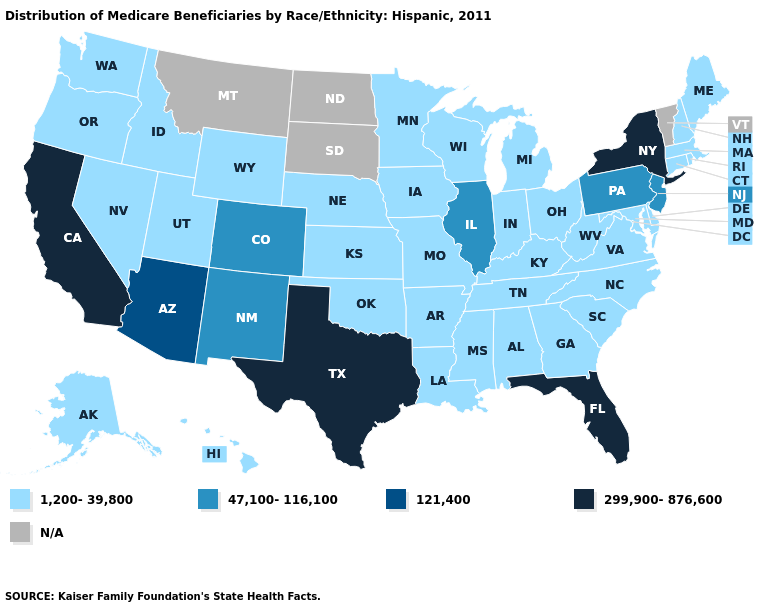Does the map have missing data?
Keep it brief. Yes. What is the value of Oregon?
Be succinct. 1,200-39,800. Which states hav the highest value in the South?
Concise answer only. Florida, Texas. What is the lowest value in states that border Utah?
Be succinct. 1,200-39,800. Does the first symbol in the legend represent the smallest category?
Concise answer only. Yes. Name the states that have a value in the range 1,200-39,800?
Concise answer only. Alabama, Alaska, Arkansas, Connecticut, Delaware, Georgia, Hawaii, Idaho, Indiana, Iowa, Kansas, Kentucky, Louisiana, Maine, Maryland, Massachusetts, Michigan, Minnesota, Mississippi, Missouri, Nebraska, Nevada, New Hampshire, North Carolina, Ohio, Oklahoma, Oregon, Rhode Island, South Carolina, Tennessee, Utah, Virginia, Washington, West Virginia, Wisconsin, Wyoming. Among the states that border California , does Arizona have the highest value?
Be succinct. Yes. Name the states that have a value in the range 47,100-116,100?
Give a very brief answer. Colorado, Illinois, New Jersey, New Mexico, Pennsylvania. Which states have the highest value in the USA?
Be succinct. California, Florida, New York, Texas. What is the value of Hawaii?
Keep it brief. 1,200-39,800. Name the states that have a value in the range 47,100-116,100?
Short answer required. Colorado, Illinois, New Jersey, New Mexico, Pennsylvania. Which states have the lowest value in the USA?
Keep it brief. Alabama, Alaska, Arkansas, Connecticut, Delaware, Georgia, Hawaii, Idaho, Indiana, Iowa, Kansas, Kentucky, Louisiana, Maine, Maryland, Massachusetts, Michigan, Minnesota, Mississippi, Missouri, Nebraska, Nevada, New Hampshire, North Carolina, Ohio, Oklahoma, Oregon, Rhode Island, South Carolina, Tennessee, Utah, Virginia, Washington, West Virginia, Wisconsin, Wyoming. Name the states that have a value in the range 47,100-116,100?
Give a very brief answer. Colorado, Illinois, New Jersey, New Mexico, Pennsylvania. What is the value of Colorado?
Keep it brief. 47,100-116,100. Does Nevada have the highest value in the USA?
Write a very short answer. No. 